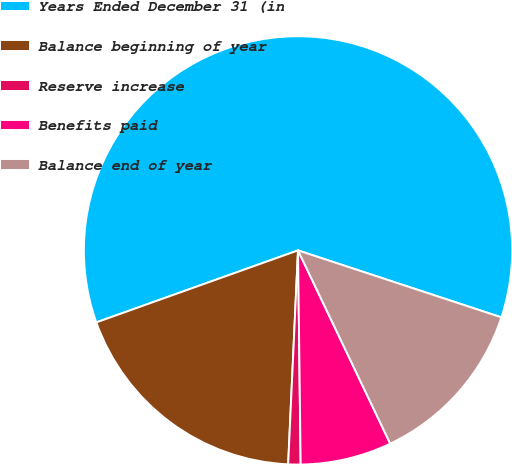Convert chart to OTSL. <chart><loc_0><loc_0><loc_500><loc_500><pie_chart><fcel>Years Ended December 31 (in<fcel>Balance beginning of year<fcel>Reserve increase<fcel>Benefits paid<fcel>Balance end of year<nl><fcel>60.52%<fcel>18.81%<fcel>0.93%<fcel>6.89%<fcel>12.85%<nl></chart> 